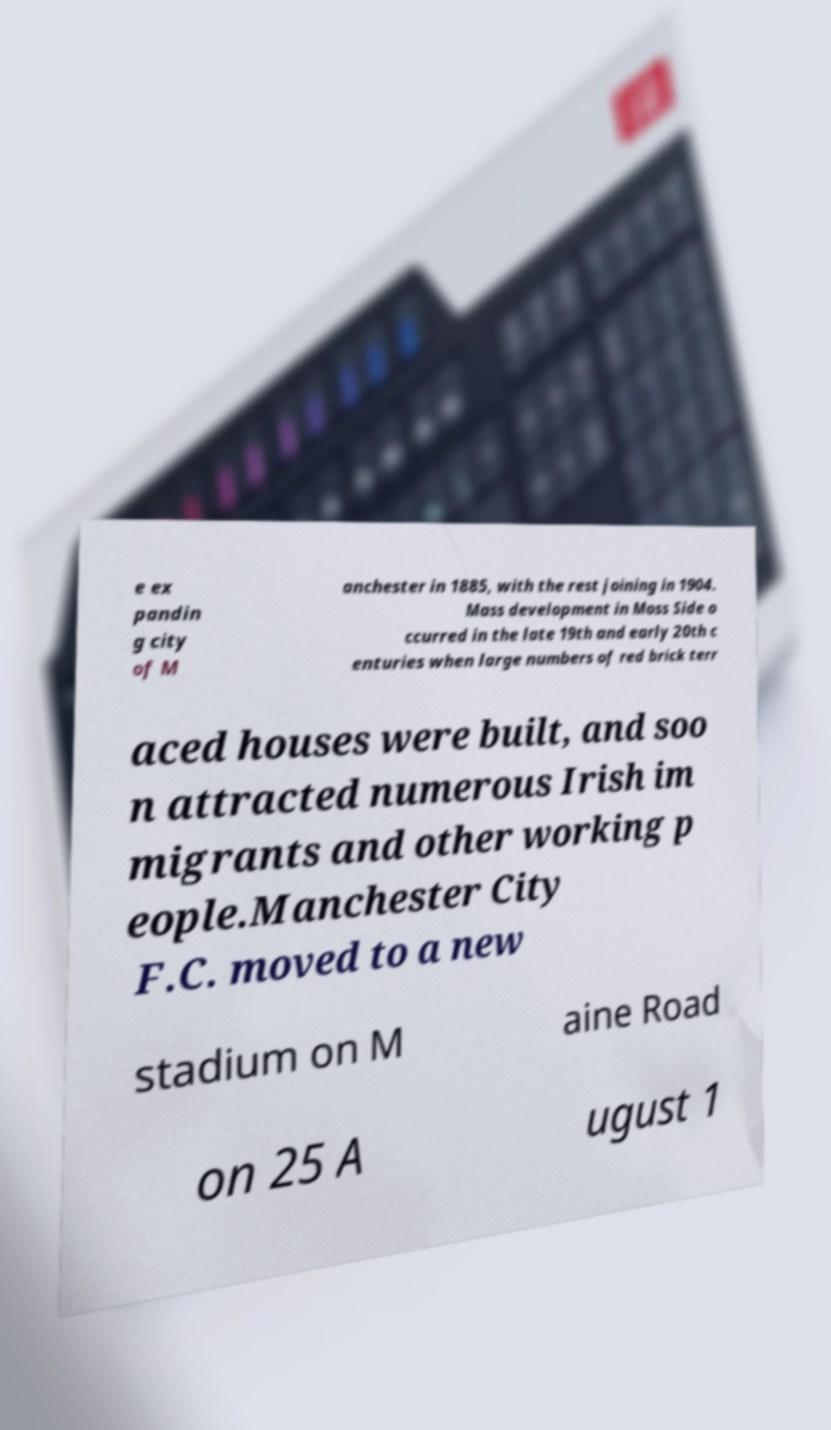Can you accurately transcribe the text from the provided image for me? e ex pandin g city of M anchester in 1885, with the rest joining in 1904. Mass development in Moss Side o ccurred in the late 19th and early 20th c enturies when large numbers of red brick terr aced houses were built, and soo n attracted numerous Irish im migrants and other working p eople.Manchester City F.C. moved to a new stadium on M aine Road on 25 A ugust 1 